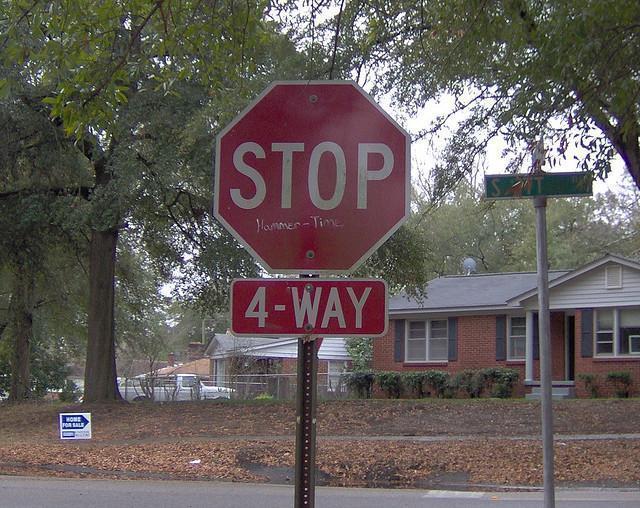How many lanes have to stop?
Give a very brief answer. 4. 